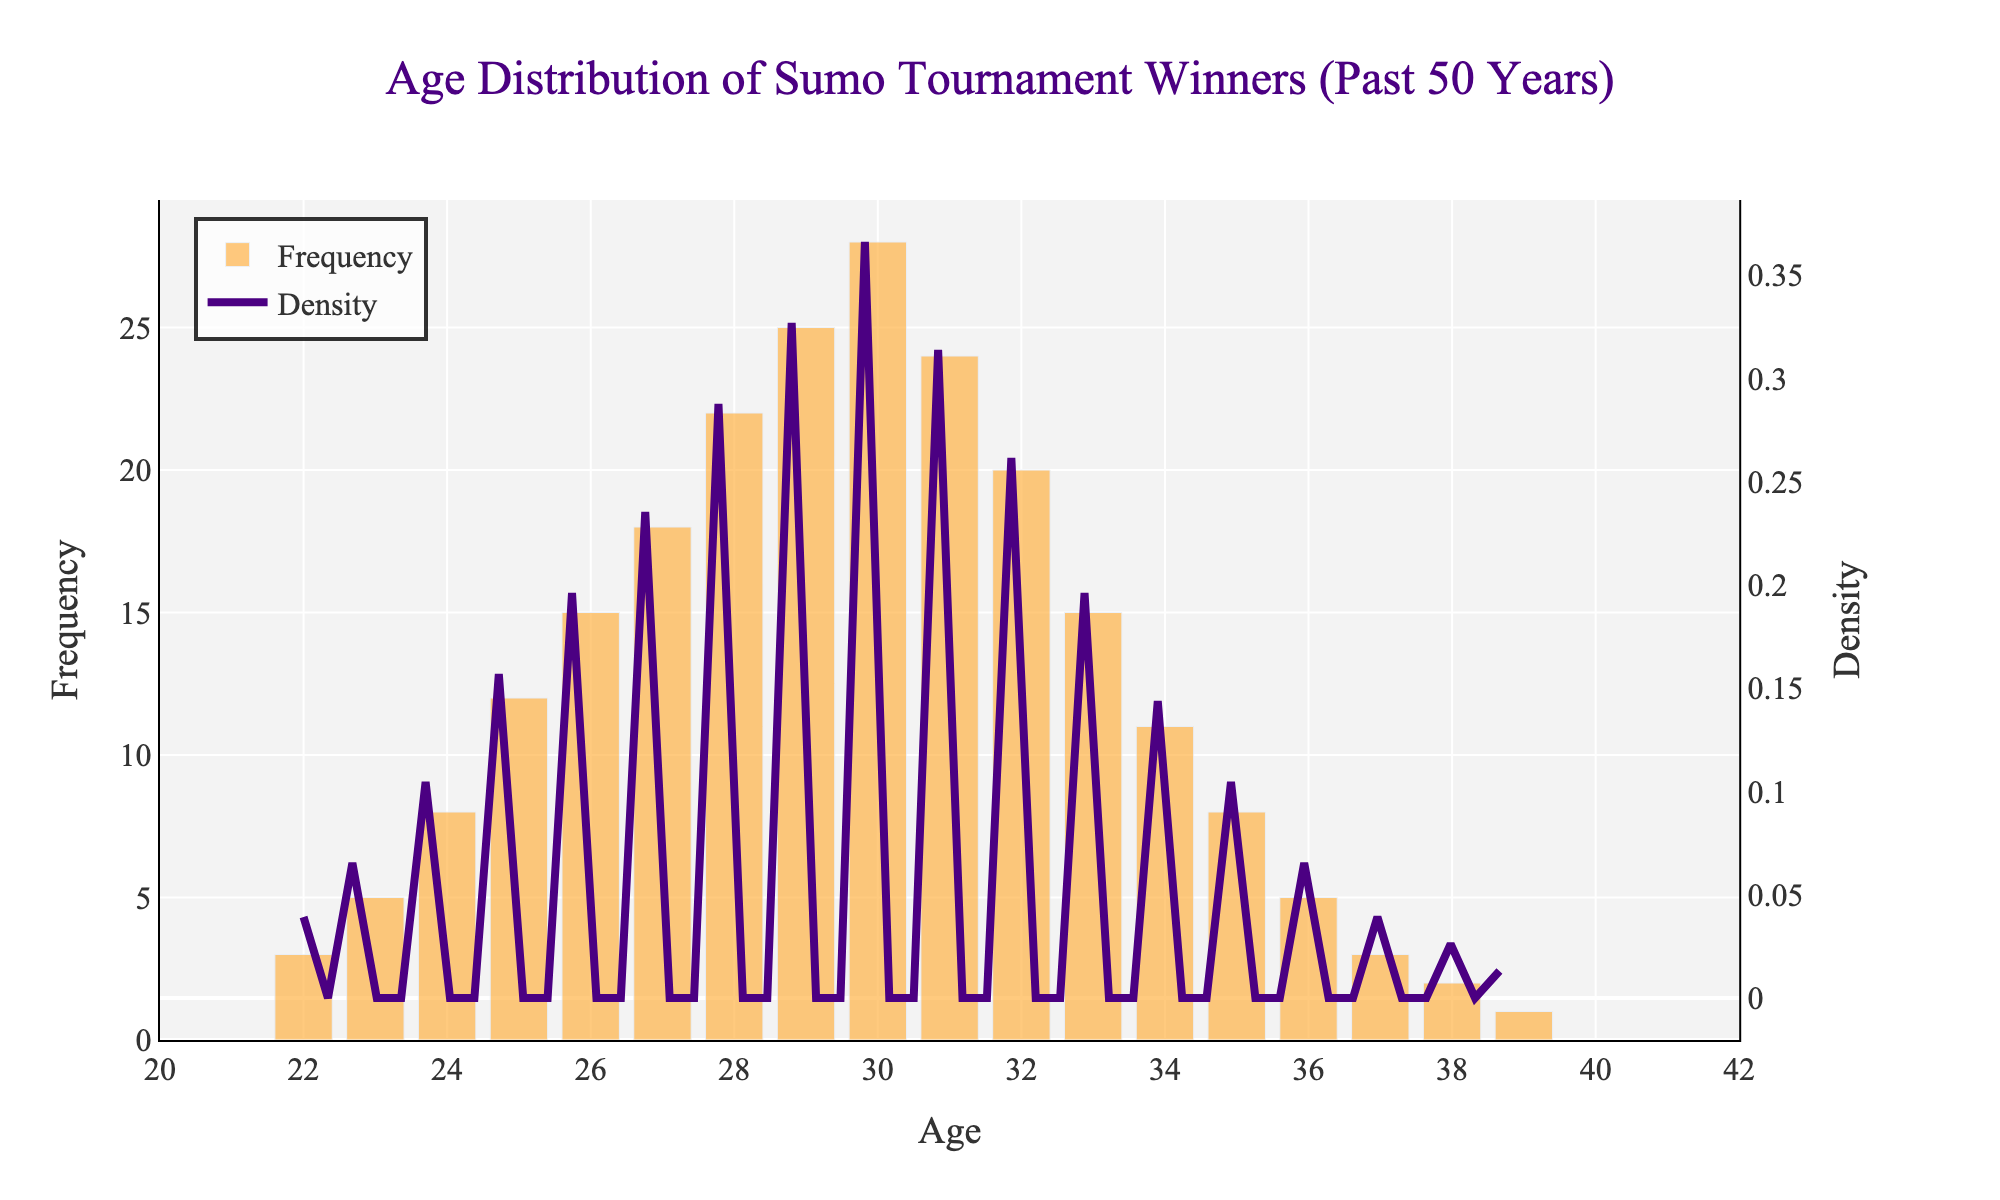What is the title of the figure? The title is usually the most prominent text at the top of a figure that describes its purpose. In this case, it is placed centrally and uses a distinct font and color.
Answer: Age Distribution of Sumo Tournament Winners (Past 50 Years) What color is used for the histogram bars? The color used for the histogram bars can be identified directly from the visual representation. These bars are filled with a specific shade that stands out in the chart. In this figure, they are a light orange.
Answer: Light orange What does the KDE (density curve) represent in the figure? The density curve shows the smoothed distribution of data, which helps in understanding the underlying distribution shape. In the figure, this curve is drawn in a distinct color and represents how the age of sumo tournament winners is distributed.
Answer: It represents the density of the age distribution At what age is the frequency of sumo tournament winners highest? By observing the heights of the histogram bars, we can determine the age with the highest frequency. The tallest bar indicates the age group with the most winners.
Answer: 30 Which age range shows a noticeable decline in the frequency of sumo tournament winners? We need to identify the age range by looking at the histogram bars from a peak downwards, indicating a decline. Here, after the age of 30, there is a noticeable decline.
Answer: 31 to 39 What is the approximate density value at age 30? By looking at the density curve and checking its position at age 30 on the x-axis, we can estimate the density value from the y-axis on the secondary (density) scale.
Answer: Approximately 0.07 How many times more frequent are winners at age 30 compared to age 22? By comparing the heights of the histogram bars, we can determine how many more times frequent winners are at the peak age compared to another age. Age 30 has a frequency of 28, while age 22 has a frequency of 3.
Answer: 9.33 times more frequent Which side of the age distribution graph has a steeper decline, the younger or older side? We compare the slopes of the histogram bars and the density curve on both sides of the age peak. The side with a steeper slope indicates a faster decline in frequency.
Answer: Older side 